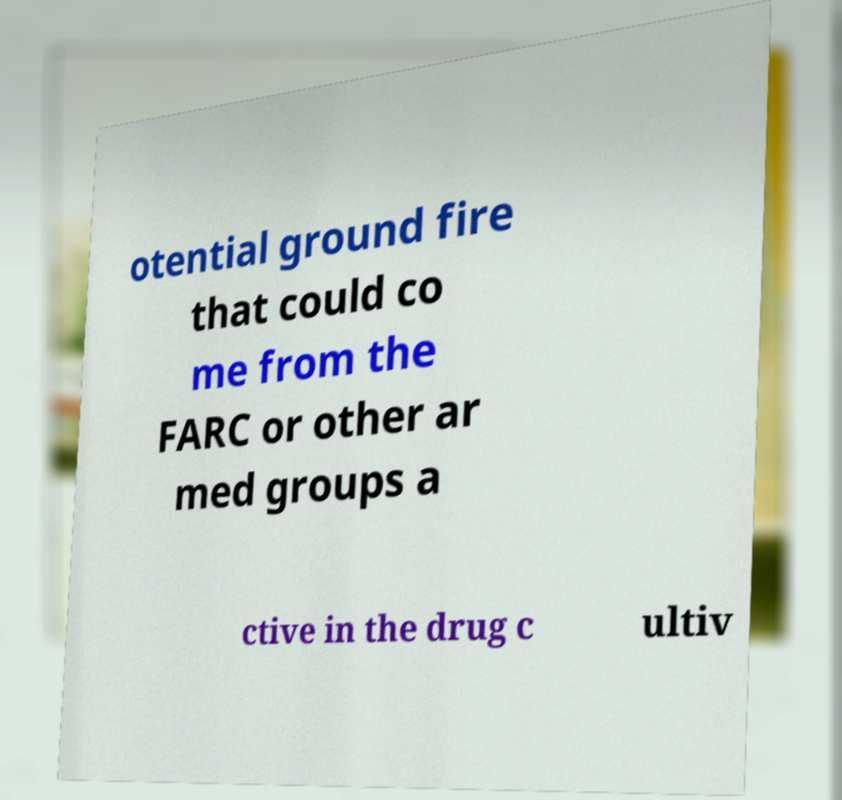What messages or text are displayed in this image? I need them in a readable, typed format. otential ground fire that could co me from the FARC or other ar med groups a ctive in the drug c ultiv 